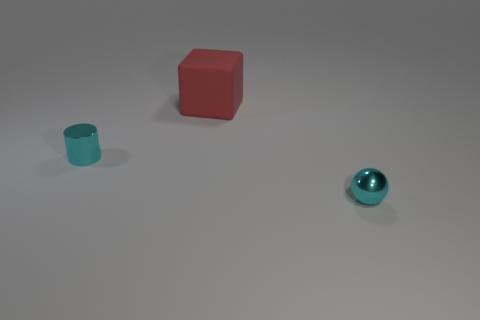There is a thing that is right of the tiny cyan cylinder and in front of the large red matte block; what color is it?
Offer a terse response. Cyan. Is the number of brown rubber cylinders greater than the number of small metallic things?
Provide a short and direct response. No. Does the tiny metal object left of the big red rubber object have the same shape as the big rubber thing?
Make the answer very short. No. What number of shiny things are either big blocks or cyan cylinders?
Your response must be concise. 1. Are there any tiny green cubes that have the same material as the cylinder?
Your answer should be compact. No. What is the block made of?
Your answer should be compact. Rubber. There is a tiny metal object left of the small cyan object that is to the right of the cyan shiny cylinder behind the tiny metallic ball; what shape is it?
Give a very brief answer. Cylinder. Are there more small things that are left of the cube than small rubber spheres?
Ensure brevity in your answer.  Yes. Do the big rubber thing and the thing that is to the right of the large rubber block have the same shape?
Offer a terse response. No. What shape is the thing that is the same color as the metal cylinder?
Offer a terse response. Sphere. 